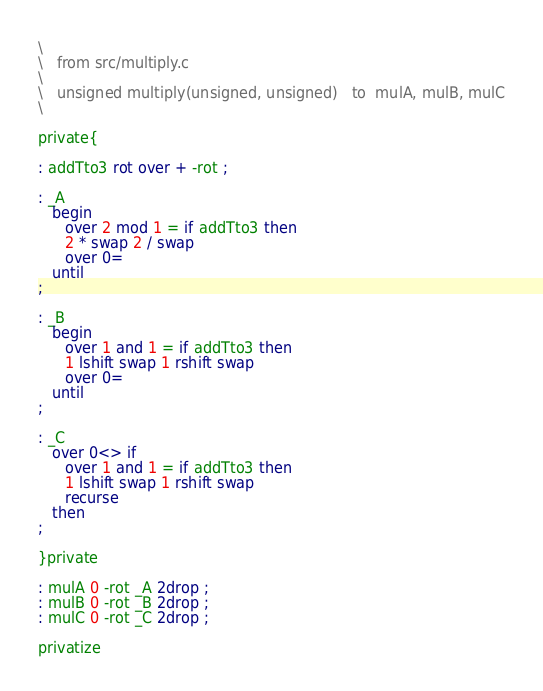Convert code to text. <code><loc_0><loc_0><loc_500><loc_500><_Forth_>\
\	from src/multiply.c
\
\	unsigned multiply(unsigned, unsigned)	to	mulA, mulB, mulC
\

private{

: addTto3 rot over + -rot ;

: _A
   begin
      over 2 mod 1 = if addTto3 then
      2 * swap 2 / swap
      over 0=
   until
;

: _B
   begin
      over 1 and 1 = if addTto3 then
      1 lshift swap 1 rshift swap
      over 0=
   until
;

: _C
   over 0<> if
      over 1 and 1 = if addTto3 then
      1 lshift swap 1 rshift swap
      recurse
   then
;

}private

: mulA 0 -rot _A 2drop ;
: mulB 0 -rot _B 2drop ;
: mulC 0 -rot _C 2drop ;

privatize
</code> 